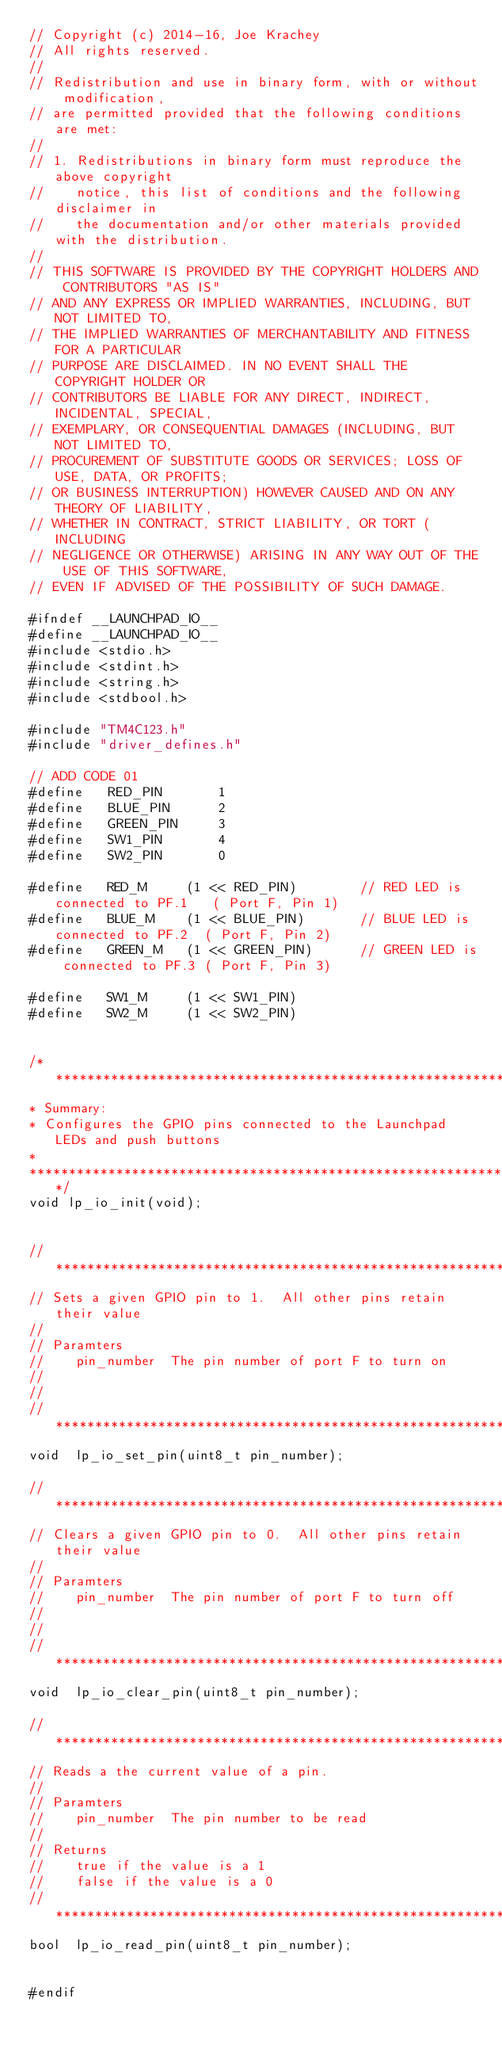<code> <loc_0><loc_0><loc_500><loc_500><_C_>// Copyright (c) 2014-16, Joe Krachey
// All rights reserved.
//
// Redistribution and use in binary form, with or without modification, 
// are permitted provided that the following conditions are met:
//
// 1. Redistributions in binary form must reproduce the above copyright 
//    notice, this list of conditions and the following disclaimer in 
//    the documentation and/or other materials provided with the distribution.
//
// THIS SOFTWARE IS PROVIDED BY THE COPYRIGHT HOLDERS AND CONTRIBUTORS "AS IS" 
// AND ANY EXPRESS OR IMPLIED WARRANTIES, INCLUDING, BUT NOT LIMITED TO, 
// THE IMPLIED WARRANTIES OF MERCHANTABILITY AND FITNESS FOR A PARTICULAR 
// PURPOSE ARE DISCLAIMED. IN NO EVENT SHALL THE COPYRIGHT HOLDER OR 
// CONTRIBUTORS BE LIABLE FOR ANY DIRECT, INDIRECT, INCIDENTAL, SPECIAL, 
// EXEMPLARY, OR CONSEQUENTIAL DAMAGES (INCLUDING, BUT NOT LIMITED TO, 
// PROCUREMENT OF SUBSTITUTE GOODS OR SERVICES; LOSS OF USE, DATA, OR PROFITS; 
// OR BUSINESS INTERRUPTION) HOWEVER CAUSED AND ON ANY THEORY OF LIABILITY, 
// WHETHER IN CONTRACT, STRICT LIABILITY, OR TORT (INCLUDING 
// NEGLIGENCE OR OTHERWISE) ARISING IN ANY WAY OUT OF THE USE OF THIS SOFTWARE, 
// EVEN IF ADVISED OF THE POSSIBILITY OF SUCH DAMAGE.

#ifndef __LAUNCHPAD_IO__
#define __LAUNCHPAD_IO__
#include <stdio.h>
#include <stdint.h>
#include <string.h>
#include <stdbool.h>

#include "TM4C123.h"
#include "driver_defines.h"

// ADD CODE 01
#define   RED_PIN       1
#define   BLUE_PIN      2
#define   GREEN_PIN     3
#define   SW1_PIN       4
#define   SW2_PIN       0

#define   RED_M     (1 << RED_PIN)        // RED LED is connected to PF.1   ( Port F, Pin 1)
#define   BLUE_M    (1 << BLUE_PIN)       // BLUE LED is connected to PF.2  ( Port F, Pin 2)
#define   GREEN_M   (1 << GREEN_PIN)      // GREEN LED is connected to PF.3 ( Port F, Pin 3)

#define   SW1_M     (1 << SW1_PIN)
#define   SW2_M     (1 << SW2_PIN)


/********************************************************************************
* Summary:
* Configures the GPIO pins connected to the Launchpad LEDs and push buttons
*
*******************************************************************************/
void lp_io_init(void);


//*****************************************************************************
// Sets a given GPIO pin to 1.  All other pins retain their value
//
// Paramters
//    pin_number  The pin number of port F to turn on
//              
//
//*****************************************************************************
void  lp_io_set_pin(uint8_t pin_number);

//*****************************************************************************
// Clears a given GPIO pin to 0.  All other pins retain their value
//
// Paramters
//    pin_number  The pin number of port F to turn off
//              
//
//*****************************************************************************
void  lp_io_clear_pin(uint8_t pin_number);

//*****************************************************************************
// Reads a the current value of a pin.
//
// Paramters
//    pin_number  The pin number to be read
//              
// Returns
//    true if the value is a 1 
//    false if the value is a 0
//*****************************************************************************
bool  lp_io_read_pin(uint8_t pin_number);


#endif
</code> 